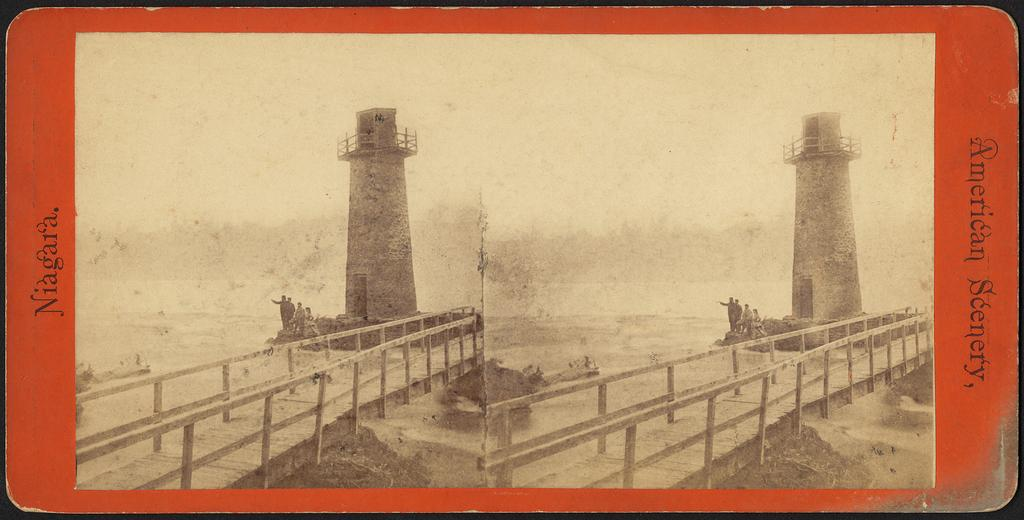Provide a one-sentence caption for the provided image. An old looking card has two lighthouses pictured on it from Niagara. 